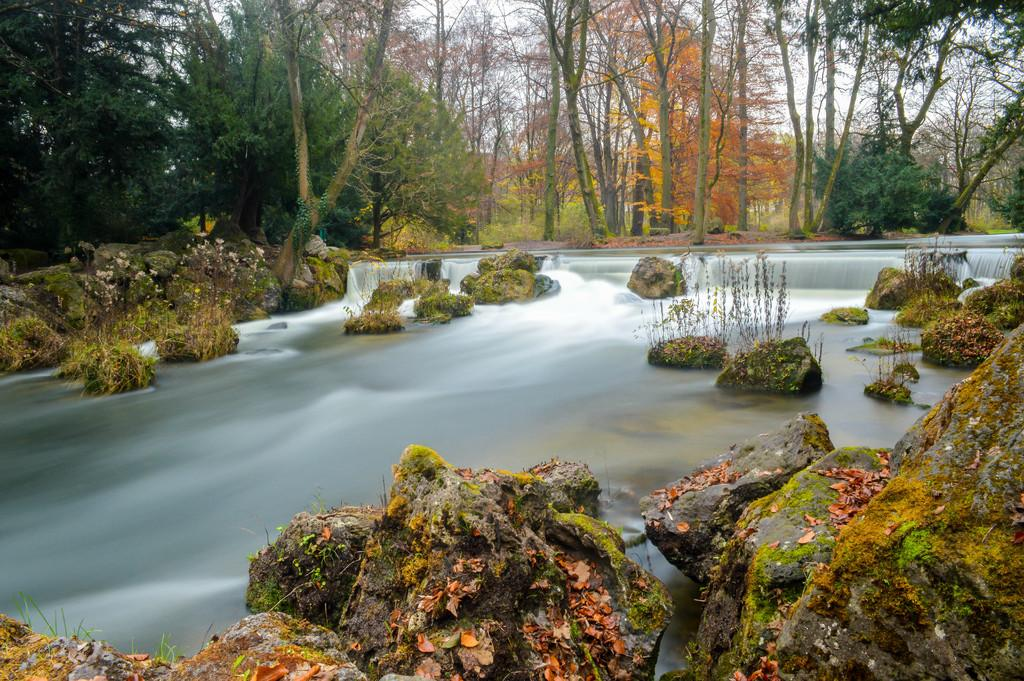What natural element is visible in the image? Water is visible in the image. What type of geological formations can be seen in the image? There are rocks in the image. What type of vegetation is present in the image? There are plants and trees in the image. What part of the natural environment is visible in the background of the image? The sky is visible in the background of the image. What type of cattle can be seen grazing in the image? There is no cattle present in the image. How does the water rub against the rocks in the image? The water does not rub against the rocks in the image; it is stationary. 